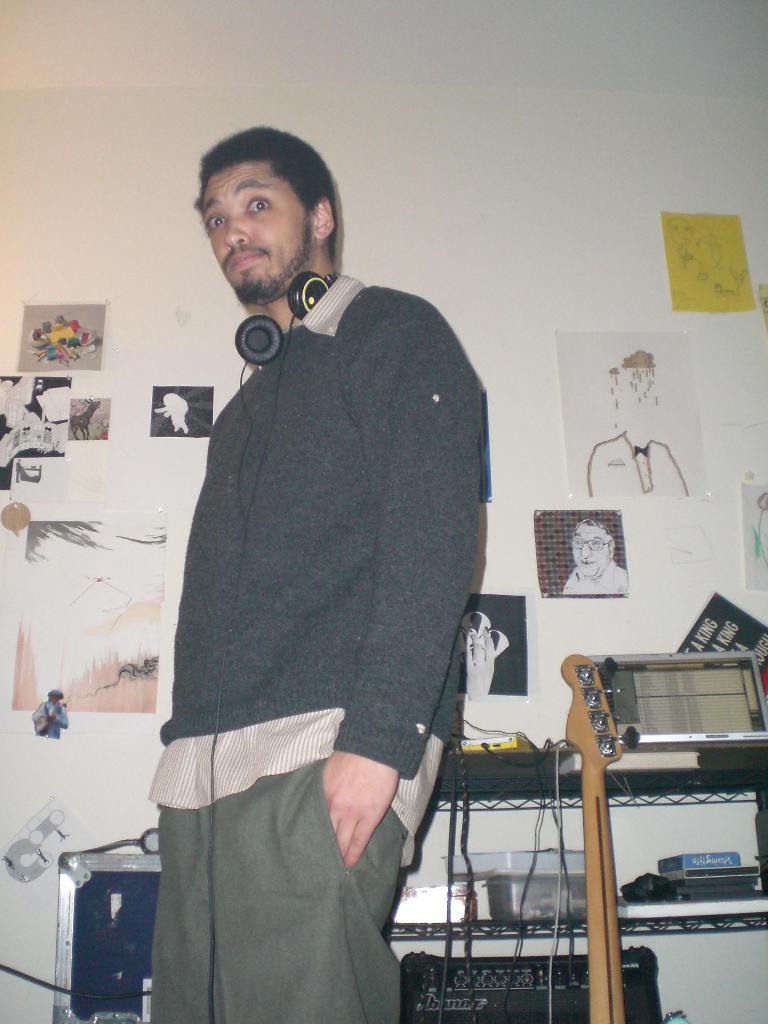How would you summarize this image in a sentence or two? In this image we can see a person standing wearing a headset to his neck. On the backside we can see some pictures pasted on the wall. On the right side we can see a table containing a laptop, guitar, wires, box and some containers on it. 